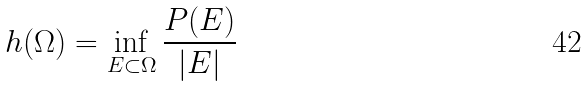Convert formula to latex. <formula><loc_0><loc_0><loc_500><loc_500>h ( \Omega ) = \inf _ { E \subset \Omega } \frac { P ( E ) } { | E | }</formula> 